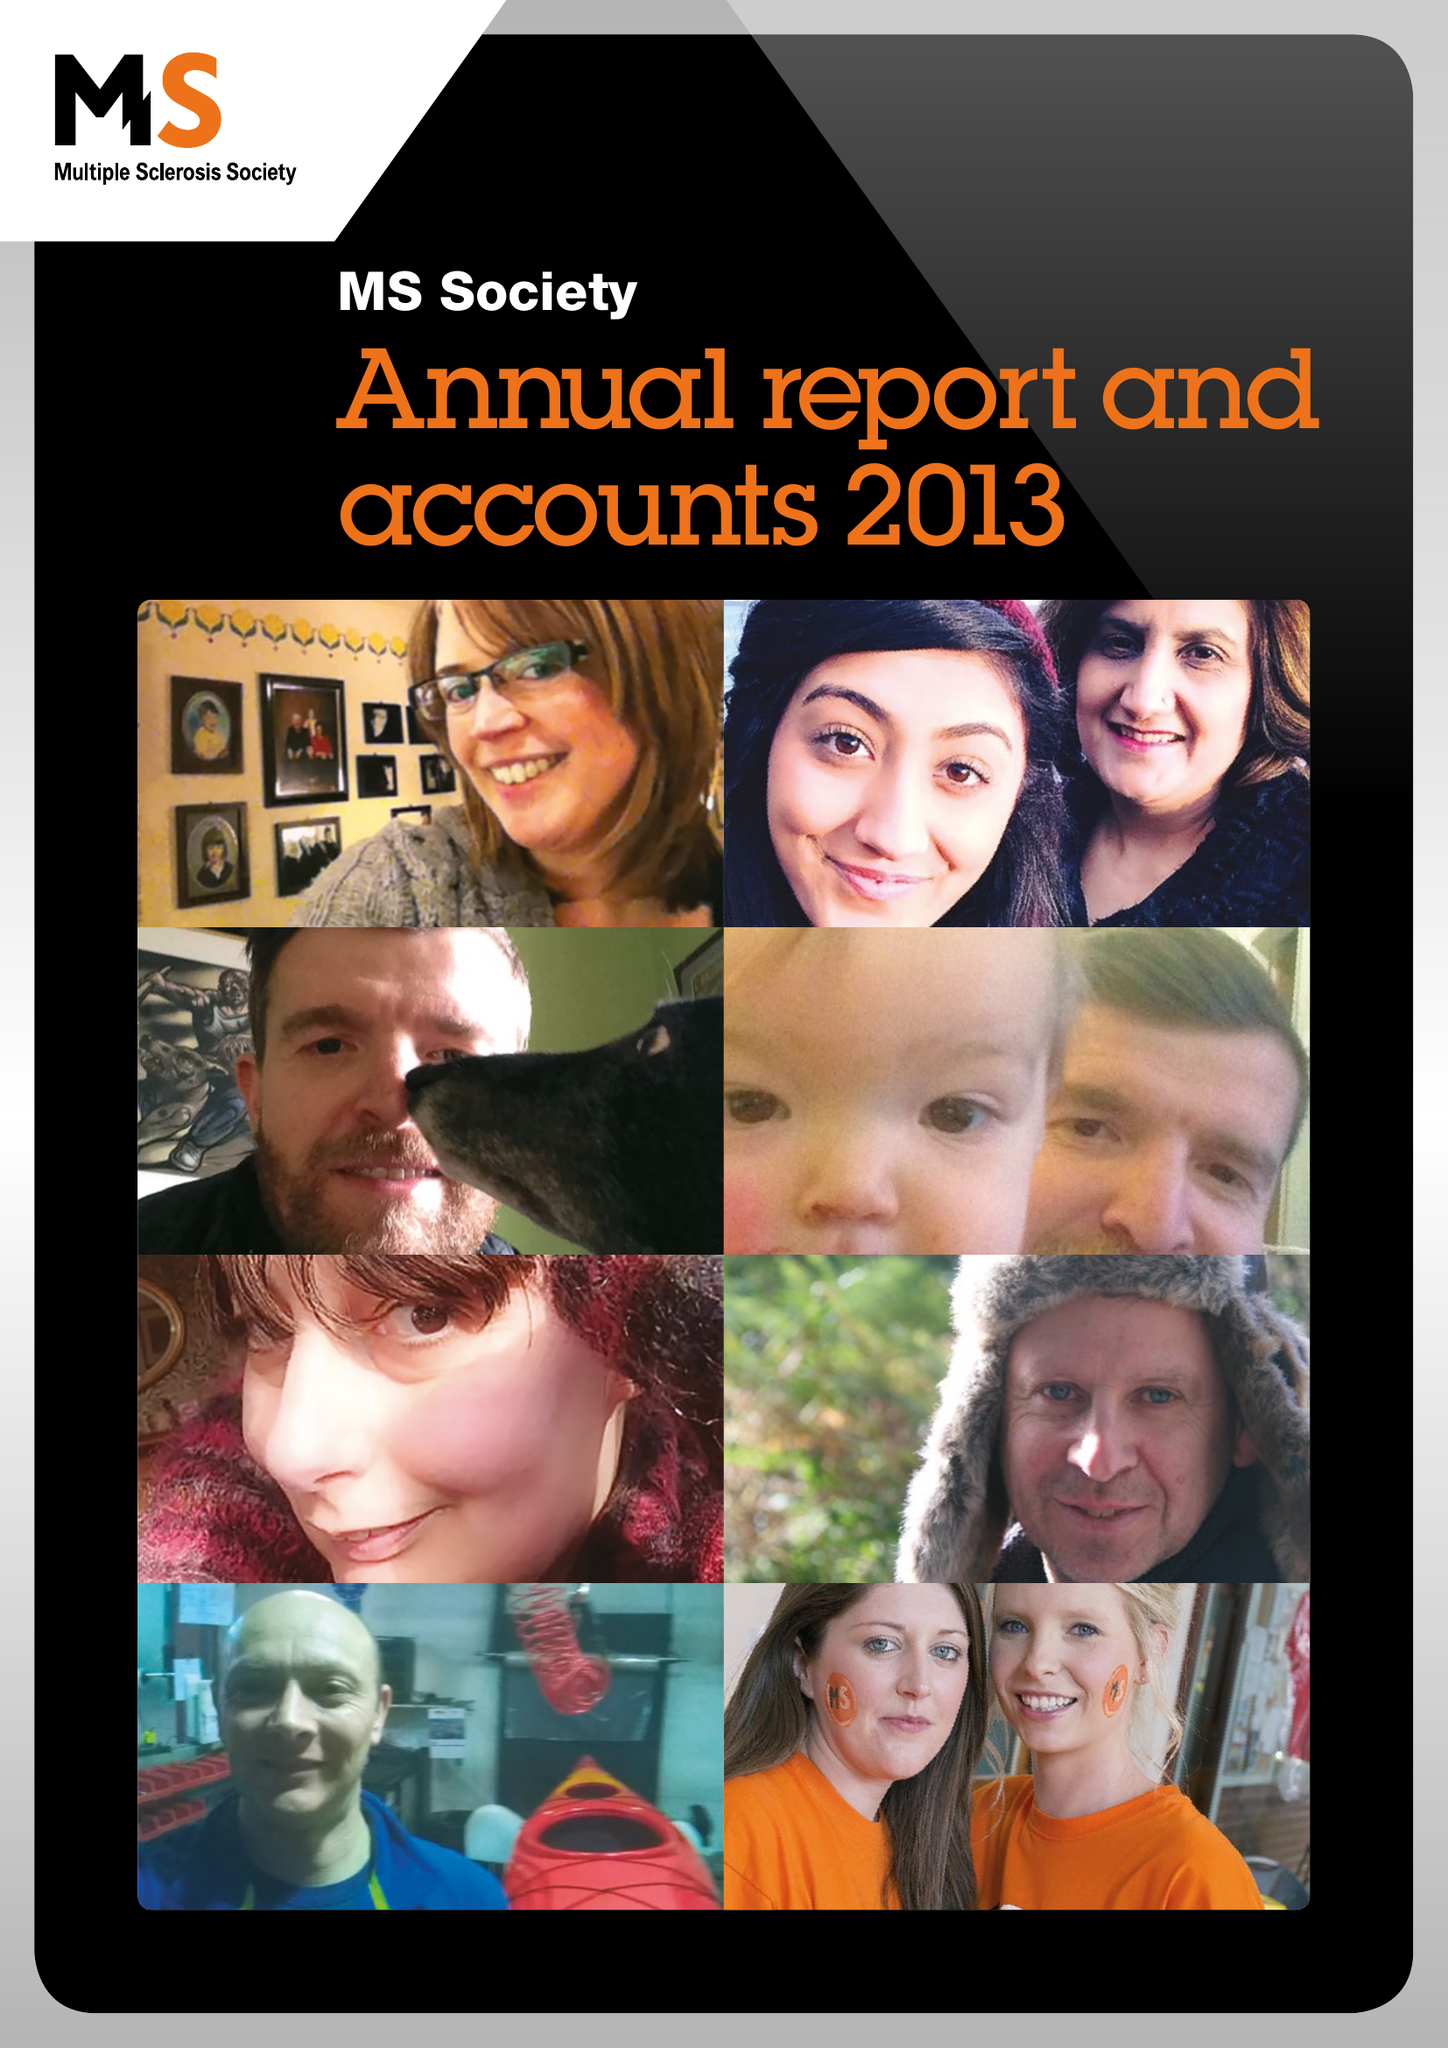What is the value for the address__post_town?
Answer the question using a single word or phrase. LONDON 